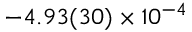Convert formula to latex. <formula><loc_0><loc_0><loc_500><loc_500>- 4 . 9 3 ( 3 0 ) \times 1 0 ^ { - 4 }</formula> 